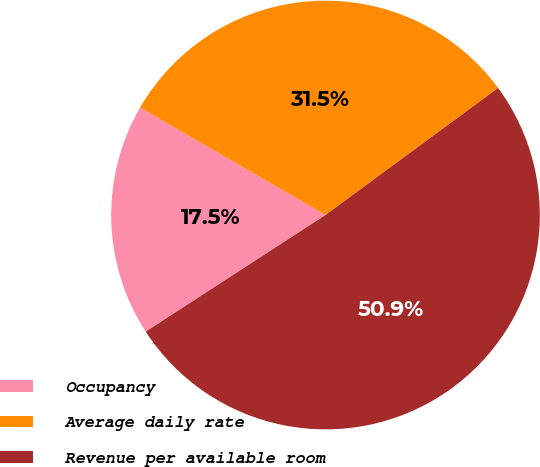Convert chart. <chart><loc_0><loc_0><loc_500><loc_500><pie_chart><fcel>Occupancy<fcel>Average daily rate<fcel>Revenue per available room<nl><fcel>17.52%<fcel>31.54%<fcel>50.94%<nl></chart> 